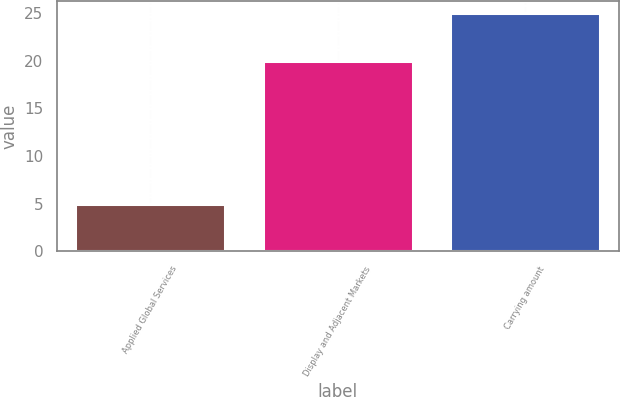<chart> <loc_0><loc_0><loc_500><loc_500><bar_chart><fcel>Applied Global Services<fcel>Display and Adjacent Markets<fcel>Carrying amount<nl><fcel>5<fcel>20<fcel>25<nl></chart> 